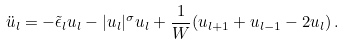Convert formula to latex. <formula><loc_0><loc_0><loc_500><loc_500>\ddot { u } _ { l } = - \tilde { \epsilon } _ { l } u _ { l } - | u _ { l } | ^ { \sigma } u _ { l } + \frac { 1 } { W } ( u _ { l + 1 } + u _ { l - 1 } - 2 u _ { l } ) \, .</formula> 